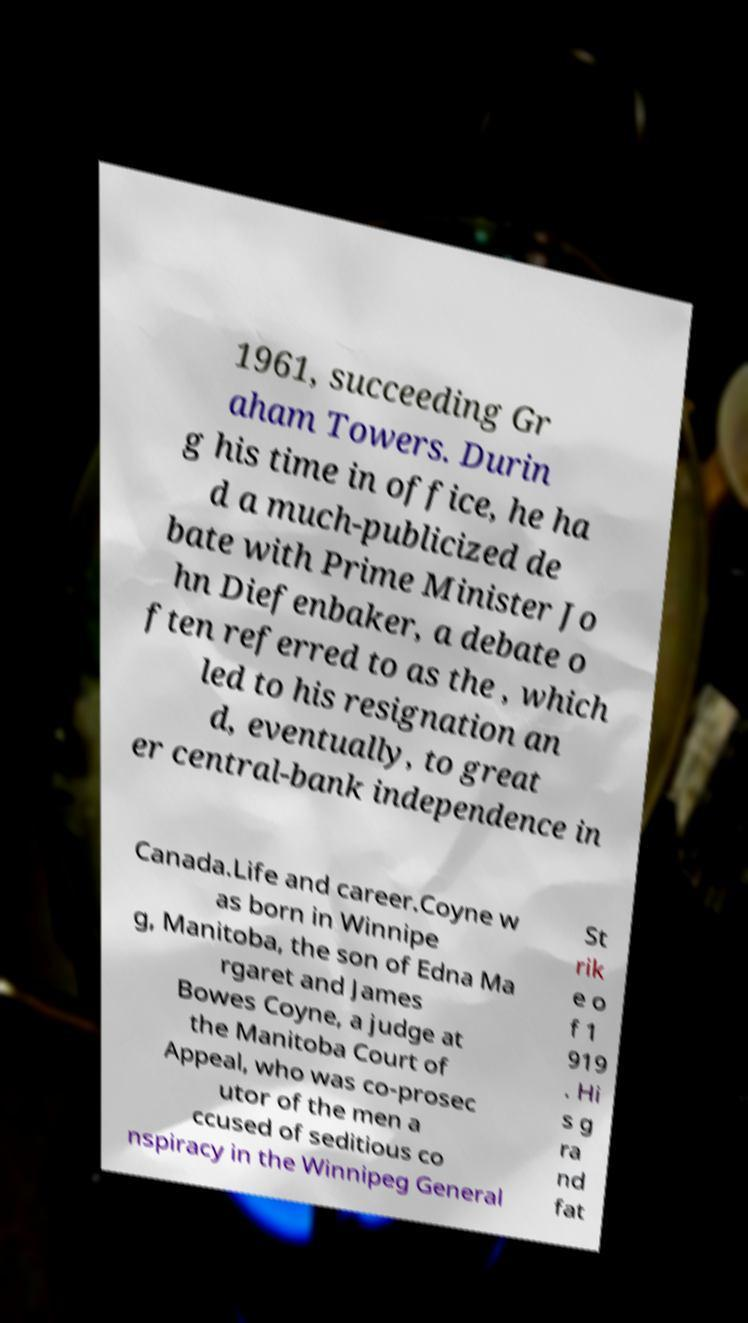Can you accurately transcribe the text from the provided image for me? 1961, succeeding Gr aham Towers. Durin g his time in office, he ha d a much-publicized de bate with Prime Minister Jo hn Diefenbaker, a debate o ften referred to as the , which led to his resignation an d, eventually, to great er central-bank independence in Canada.Life and career.Coyne w as born in Winnipe g, Manitoba, the son of Edna Ma rgaret and James Bowes Coyne, a judge at the Manitoba Court of Appeal, who was co-prosec utor of the men a ccused of seditious co nspiracy in the Winnipeg General St rik e o f 1 919 . Hi s g ra nd fat 